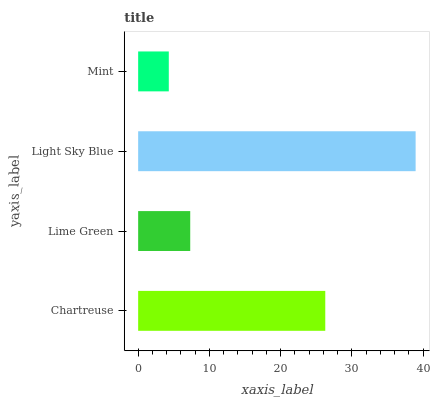Is Mint the minimum?
Answer yes or no. Yes. Is Light Sky Blue the maximum?
Answer yes or no. Yes. Is Lime Green the minimum?
Answer yes or no. No. Is Lime Green the maximum?
Answer yes or no. No. Is Chartreuse greater than Lime Green?
Answer yes or no. Yes. Is Lime Green less than Chartreuse?
Answer yes or no. Yes. Is Lime Green greater than Chartreuse?
Answer yes or no. No. Is Chartreuse less than Lime Green?
Answer yes or no. No. Is Chartreuse the high median?
Answer yes or no. Yes. Is Lime Green the low median?
Answer yes or no. Yes. Is Lime Green the high median?
Answer yes or no. No. Is Light Sky Blue the low median?
Answer yes or no. No. 